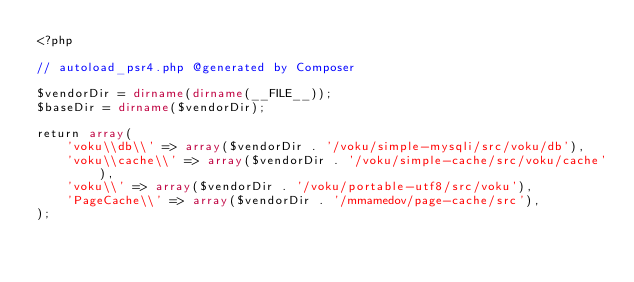<code> <loc_0><loc_0><loc_500><loc_500><_PHP_><?php

// autoload_psr4.php @generated by Composer

$vendorDir = dirname(dirname(__FILE__));
$baseDir = dirname($vendorDir);

return array(
    'voku\\db\\' => array($vendorDir . '/voku/simple-mysqli/src/voku/db'),
    'voku\\cache\\' => array($vendorDir . '/voku/simple-cache/src/voku/cache'),
    'voku\\' => array($vendorDir . '/voku/portable-utf8/src/voku'),
    'PageCache\\' => array($vendorDir . '/mmamedov/page-cache/src'),
);
</code> 